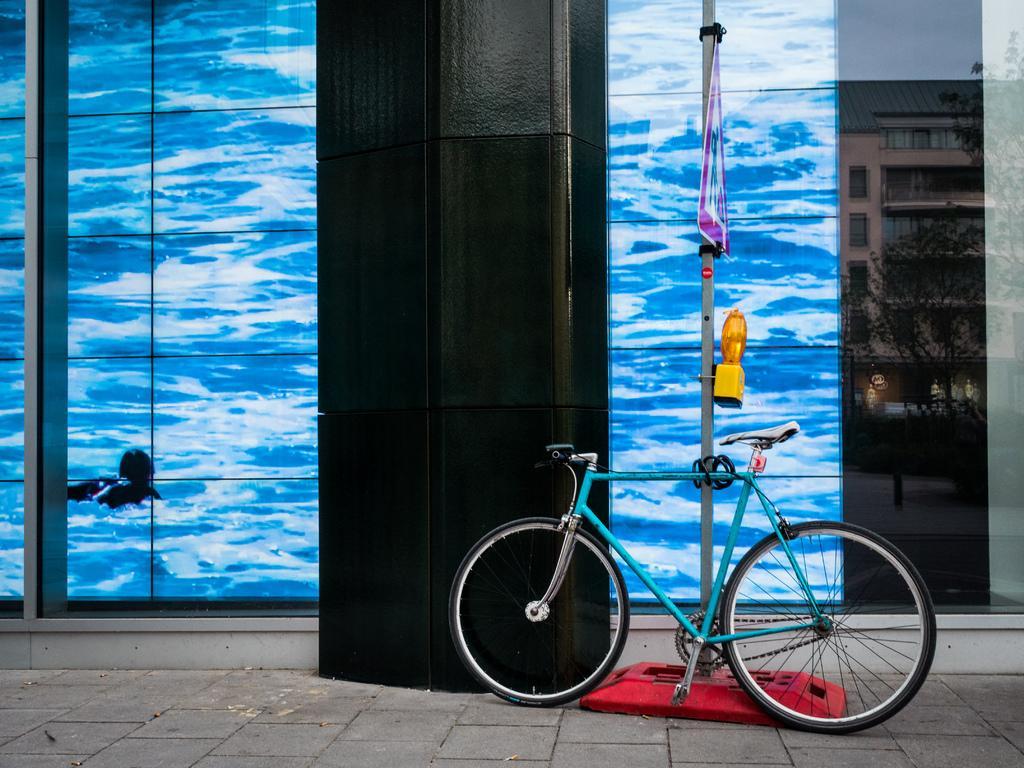Can you describe this image briefly? In this image we can see a bicycle parked aside. We can also see the flag, a pole, screen, a building with windows, some trees and the sky. 